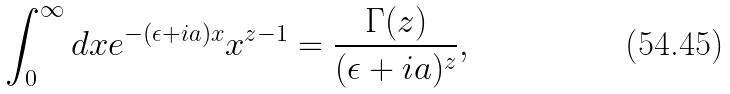Convert formula to latex. <formula><loc_0><loc_0><loc_500><loc_500>\int ^ { \infty } _ { 0 } d x e ^ { - ( \epsilon + i a ) x } x ^ { z - 1 } = \frac { \Gamma ( z ) } { ( \epsilon + i a ) ^ { z } } ,</formula> 